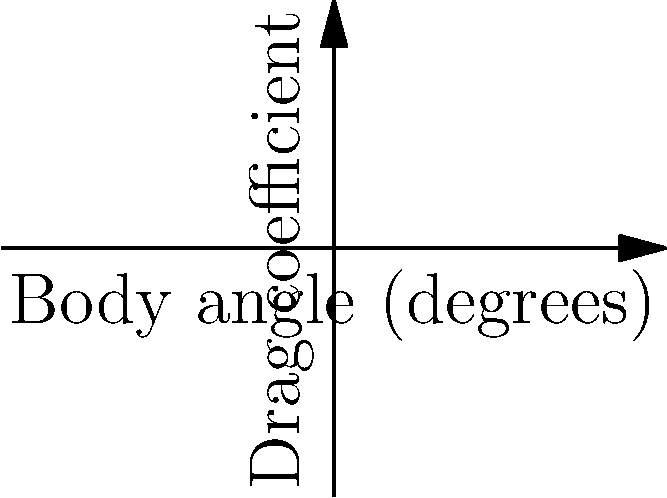Your child's swim coach has provided a graph showing the relationship between body angle and drag coefficients for front and back drag in swimming. The blue curve represents front drag, and the red curve represents back drag. The optimal body position occurs where these curves intersect. Given that the front drag function is $f(x) = 0.5x^2 - 2x + 3$ and the back drag function is $g(x) = -0.25x^2 + x + 1$, where $x$ is the body angle in degrees, determine the optimal body angle for maximum swimming speed. To find the optimal body angle, we need to solve the equation where the front drag equals the back drag:

1) Set $f(x) = g(x)$:
   $0.5x^2 - 2x + 3 = -0.25x^2 + x + 1$

2) Rearrange the equation:
   $0.5x^2 - 2x + 3 + 0.25x^2 - x - 1 = 0$
   $0.75x^2 - 3x + 2 = 0$

3) Multiply all terms by 4 to simplify:
   $3x^2 - 12x + 8 = 0$

4) This is a quadratic equation. We can solve it using the quadratic formula:
   $x = \frac{-b \pm \sqrt{b^2 - 4ac}}{2a}$

   Where $a = 3$, $b = -12$, and $c = 8$

5) Substituting these values:
   $x = \frac{12 \pm \sqrt{144 - 96}}{6} = \frac{12 \pm \sqrt{48}}{6} = \frac{12 \pm 4\sqrt{3}}{6}$

6) Simplifying:
   $x = 2 \pm \frac{2\sqrt{3}}{3}$

7) This gives us two solutions:
   $x_1 = 2 + \frac{2\sqrt{3}}{3} \approx 3.15$ and $x_2 = 2 - \frac{2\sqrt{3}}{3} \approx 0.85$

8) Looking at the graph, we can see that the curves intersect at $x = 2$, which corresponds to $x_1$.

Therefore, the optimal body angle for maximum swimming speed is approximately 2 degrees.
Answer: 2 degrees 